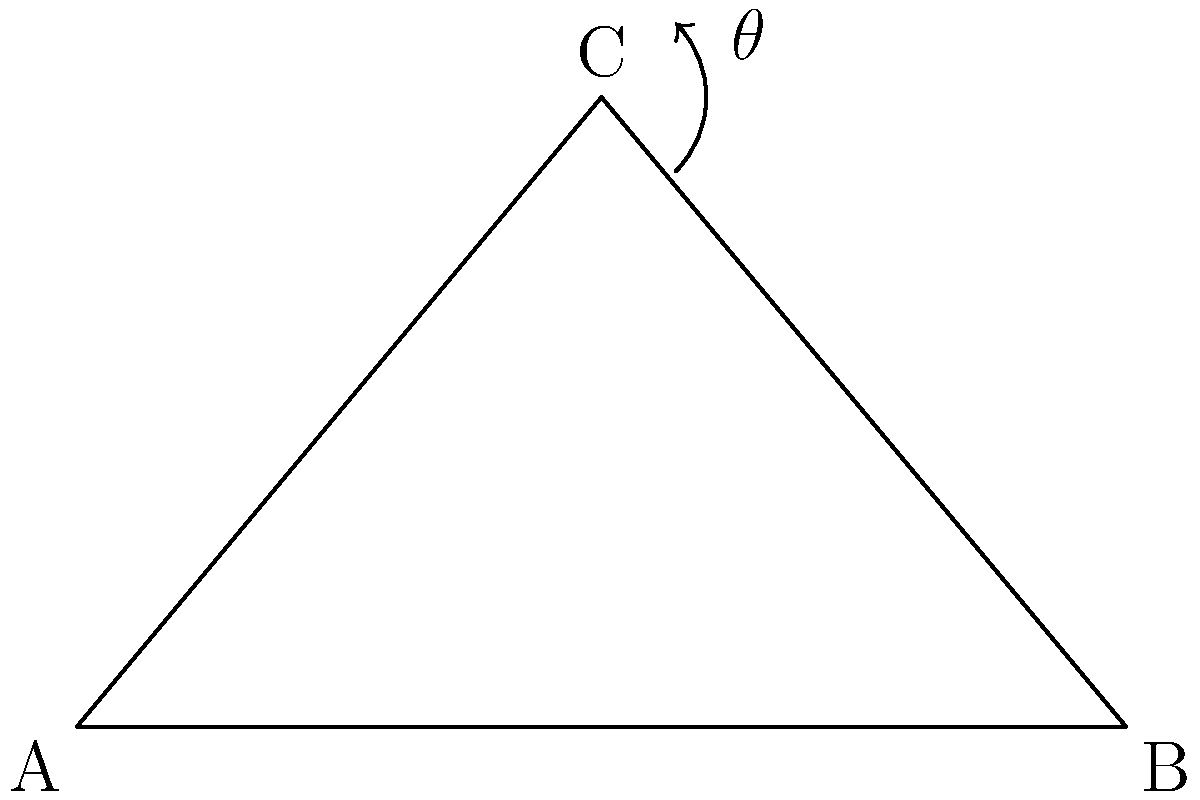In a film poster, the camera angle creates a triangular composition. If the base of the triangle is 5 units long and the height is 3 units, what is the angle $\theta$ at the apex of the triangle? To find the angle $\theta$ at the apex of the triangle, we can follow these steps:

1. Recognize that we have a right-angled triangle with the following dimensions:
   - Base (b) = 5 units
   - Height (h) = 3 units

2. We can use the tangent function to find the angle. In a right-angled triangle, 
   $\tan(\frac{\theta}{2}) = \frac{\text{opposite}}{\text{adjacent}}$

3. In this case:
   $\tan(\frac{\theta}{2}) = \frac{h}{\frac{b}{2}} = \frac{3}{\frac{5}{2}} = \frac{6}{5} = 1.2$

4. To find $\theta$, we need to use the inverse tangent (arctangent) function and multiply by 2:
   $\theta = 2 \cdot \arctan(1.2)$

5. Using a calculator or mathematical software:
   $\theta = 2 \cdot \arctan(1.2) \approx 2 \cdot 50.2° = 100.4°$

6. Rounding to the nearest degree:
   $\theta \approx 100°$

This angle represents the camera's field of view in the vertical plane, which creates the triangular composition in the film poster.
Answer: $100°$ 